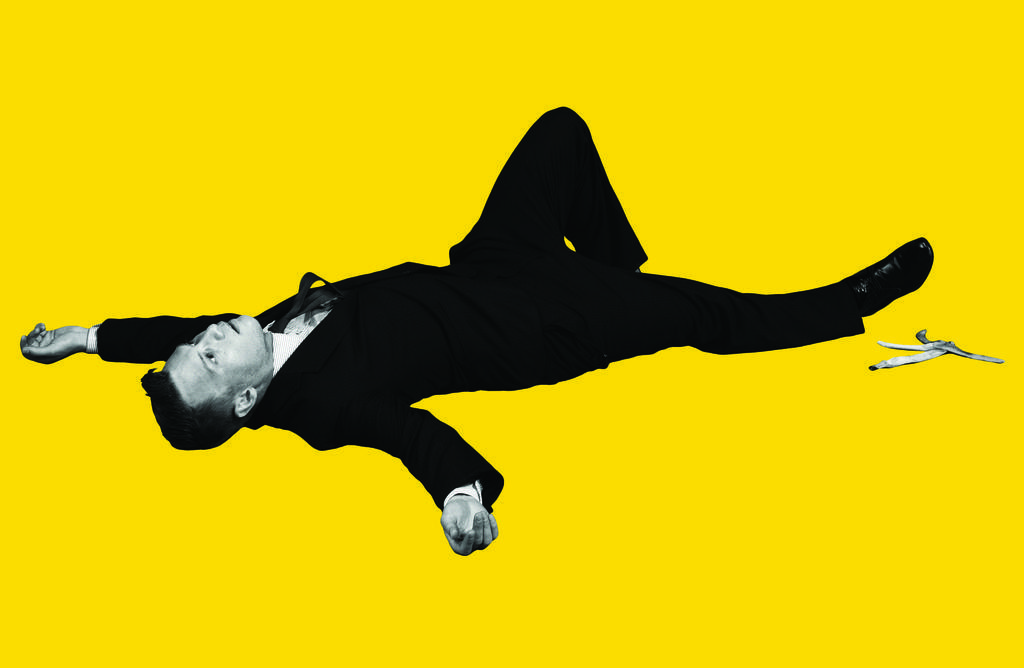Please provide a concise description of this image. In this image we can see a person with black color suit, there is a banana peel, and the background is yellow in color. 